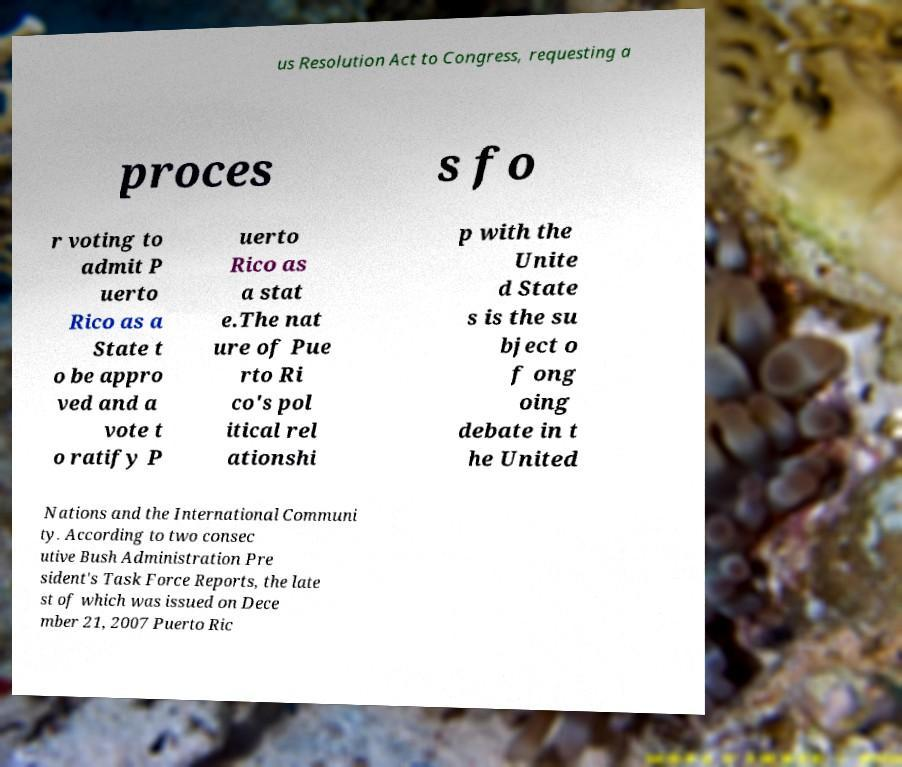Please read and relay the text visible in this image. What does it say? us Resolution Act to Congress, requesting a proces s fo r voting to admit P uerto Rico as a State t o be appro ved and a vote t o ratify P uerto Rico as a stat e.The nat ure of Pue rto Ri co's pol itical rel ationshi p with the Unite d State s is the su bject o f ong oing debate in t he United Nations and the International Communi ty. According to two consec utive Bush Administration Pre sident's Task Force Reports, the late st of which was issued on Dece mber 21, 2007 Puerto Ric 